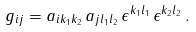<formula> <loc_0><loc_0><loc_500><loc_500>g _ { i j } = a _ { i k _ { 1 } k _ { 2 } } \, a _ { j l _ { 1 } l _ { 2 } } \, \epsilon ^ { k _ { 1 } l _ { 1 } } \, \epsilon ^ { k _ { 2 } l _ { 2 } } \, .</formula> 